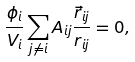Convert formula to latex. <formula><loc_0><loc_0><loc_500><loc_500>\frac { \phi _ { i } } { V _ { i } } \sum _ { j \ne i } A _ { i j } \frac { \vec { r } _ { i j } } { r _ { i j } } = 0 ,</formula> 